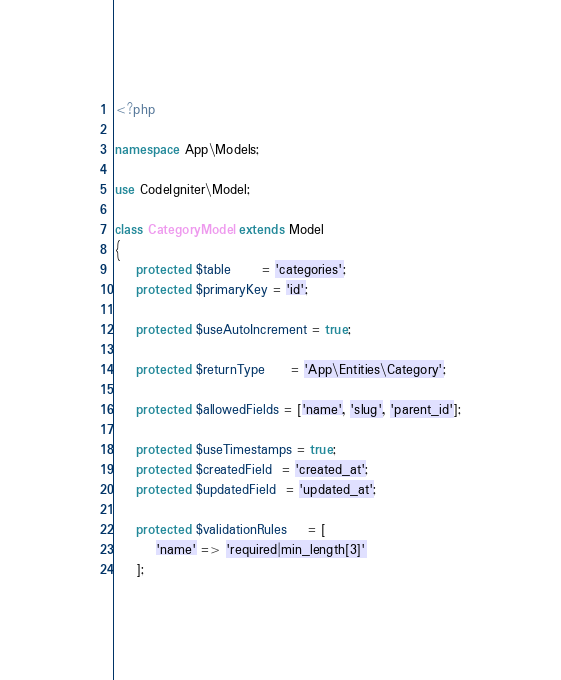<code> <loc_0><loc_0><loc_500><loc_500><_PHP_><?php

namespace App\Models;

use CodeIgniter\Model;

class CategoryModel extends Model
{
    protected $table      = 'categories';
    protected $primaryKey = 'id';

    protected $useAutoIncrement = true;

    protected $returnType     = 'App\Entities\Category';

    protected $allowedFields = ['name', 'slug', 'parent_id'];

    protected $useTimestamps = true;
    protected $createdField  = 'created_at';
    protected $updatedField  = 'updated_at';

    protected $validationRules    = [
        'name' => 'required|min_length[3]'
    ];
</code> 